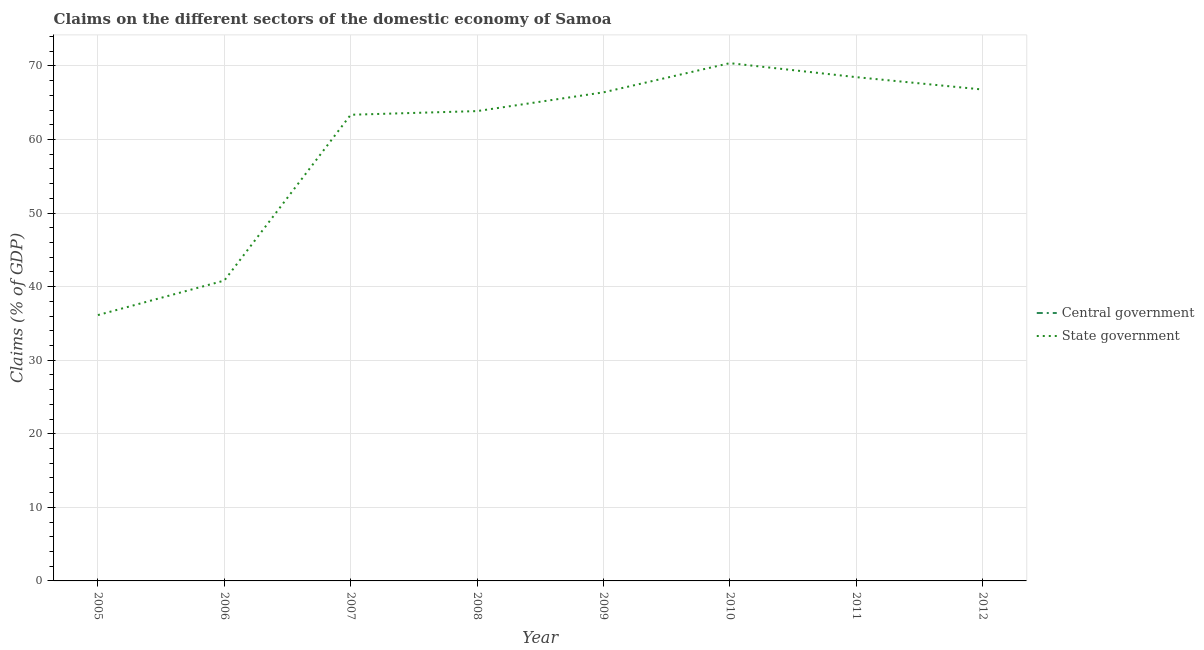Is the number of lines equal to the number of legend labels?
Offer a very short reply. No. What is the claims on state government in 2005?
Offer a terse response. 36.13. Across all years, what is the maximum claims on state government?
Provide a short and direct response. 70.37. Across all years, what is the minimum claims on central government?
Your answer should be very brief. 0. What is the total claims on state government in the graph?
Offer a very short reply. 476.19. What is the difference between the claims on state government in 2005 and that in 2006?
Keep it short and to the point. -4.69. What is the difference between the claims on state government in 2011 and the claims on central government in 2005?
Make the answer very short. 68.47. What is the average claims on state government per year?
Your answer should be very brief. 59.52. In how many years, is the claims on state government greater than 4 %?
Provide a succinct answer. 8. What is the ratio of the claims on state government in 2010 to that in 2012?
Provide a succinct answer. 1.05. What is the difference between the highest and the second highest claims on state government?
Keep it short and to the point. 1.9. What is the difference between the highest and the lowest claims on state government?
Your answer should be very brief. 34.24. In how many years, is the claims on central government greater than the average claims on central government taken over all years?
Keep it short and to the point. 0. How many years are there in the graph?
Your response must be concise. 8. What is the difference between two consecutive major ticks on the Y-axis?
Your answer should be compact. 10. Does the graph contain any zero values?
Make the answer very short. Yes. Does the graph contain grids?
Offer a terse response. Yes. Where does the legend appear in the graph?
Ensure brevity in your answer.  Center right. How are the legend labels stacked?
Provide a succinct answer. Vertical. What is the title of the graph?
Offer a terse response. Claims on the different sectors of the domestic economy of Samoa. Does "Register a property" appear as one of the legend labels in the graph?
Offer a very short reply. No. What is the label or title of the Y-axis?
Offer a terse response. Claims (% of GDP). What is the Claims (% of GDP) in State government in 2005?
Keep it short and to the point. 36.13. What is the Claims (% of GDP) in State government in 2006?
Offer a terse response. 40.82. What is the Claims (% of GDP) of State government in 2007?
Keep it short and to the point. 63.36. What is the Claims (% of GDP) in Central government in 2008?
Keep it short and to the point. 0. What is the Claims (% of GDP) of State government in 2008?
Offer a terse response. 63.85. What is the Claims (% of GDP) of Central government in 2009?
Keep it short and to the point. 0. What is the Claims (% of GDP) of State government in 2009?
Keep it short and to the point. 66.4. What is the Claims (% of GDP) in State government in 2010?
Ensure brevity in your answer.  70.37. What is the Claims (% of GDP) of Central government in 2011?
Your answer should be compact. 0. What is the Claims (% of GDP) of State government in 2011?
Provide a succinct answer. 68.47. What is the Claims (% of GDP) of State government in 2012?
Keep it short and to the point. 66.79. Across all years, what is the maximum Claims (% of GDP) in State government?
Give a very brief answer. 70.37. Across all years, what is the minimum Claims (% of GDP) in State government?
Offer a very short reply. 36.13. What is the total Claims (% of GDP) of Central government in the graph?
Keep it short and to the point. 0. What is the total Claims (% of GDP) of State government in the graph?
Your answer should be compact. 476.19. What is the difference between the Claims (% of GDP) of State government in 2005 and that in 2006?
Make the answer very short. -4.69. What is the difference between the Claims (% of GDP) in State government in 2005 and that in 2007?
Offer a very short reply. -27.22. What is the difference between the Claims (% of GDP) of State government in 2005 and that in 2008?
Keep it short and to the point. -27.72. What is the difference between the Claims (% of GDP) of State government in 2005 and that in 2009?
Your response must be concise. -30.27. What is the difference between the Claims (% of GDP) of State government in 2005 and that in 2010?
Your answer should be compact. -34.24. What is the difference between the Claims (% of GDP) in State government in 2005 and that in 2011?
Your answer should be very brief. -32.34. What is the difference between the Claims (% of GDP) in State government in 2005 and that in 2012?
Provide a succinct answer. -30.65. What is the difference between the Claims (% of GDP) of State government in 2006 and that in 2007?
Your answer should be very brief. -22.53. What is the difference between the Claims (% of GDP) in State government in 2006 and that in 2008?
Your answer should be compact. -23.03. What is the difference between the Claims (% of GDP) of State government in 2006 and that in 2009?
Provide a succinct answer. -25.58. What is the difference between the Claims (% of GDP) in State government in 2006 and that in 2010?
Offer a very short reply. -29.55. What is the difference between the Claims (% of GDP) in State government in 2006 and that in 2011?
Ensure brevity in your answer.  -27.65. What is the difference between the Claims (% of GDP) in State government in 2006 and that in 2012?
Offer a very short reply. -25.96. What is the difference between the Claims (% of GDP) of State government in 2007 and that in 2008?
Make the answer very short. -0.5. What is the difference between the Claims (% of GDP) in State government in 2007 and that in 2009?
Offer a terse response. -3.05. What is the difference between the Claims (% of GDP) in State government in 2007 and that in 2010?
Offer a terse response. -7.01. What is the difference between the Claims (% of GDP) of State government in 2007 and that in 2011?
Offer a terse response. -5.11. What is the difference between the Claims (% of GDP) in State government in 2007 and that in 2012?
Ensure brevity in your answer.  -3.43. What is the difference between the Claims (% of GDP) of State government in 2008 and that in 2009?
Make the answer very short. -2.55. What is the difference between the Claims (% of GDP) in State government in 2008 and that in 2010?
Your answer should be very brief. -6.52. What is the difference between the Claims (% of GDP) in State government in 2008 and that in 2011?
Keep it short and to the point. -4.62. What is the difference between the Claims (% of GDP) of State government in 2008 and that in 2012?
Provide a succinct answer. -2.93. What is the difference between the Claims (% of GDP) of State government in 2009 and that in 2010?
Provide a short and direct response. -3.97. What is the difference between the Claims (% of GDP) of State government in 2009 and that in 2011?
Your answer should be compact. -2.07. What is the difference between the Claims (% of GDP) in State government in 2009 and that in 2012?
Ensure brevity in your answer.  -0.38. What is the difference between the Claims (% of GDP) of State government in 2010 and that in 2011?
Your response must be concise. 1.9. What is the difference between the Claims (% of GDP) of State government in 2010 and that in 2012?
Your answer should be very brief. 3.58. What is the difference between the Claims (% of GDP) of State government in 2011 and that in 2012?
Give a very brief answer. 1.68. What is the average Claims (% of GDP) in State government per year?
Keep it short and to the point. 59.52. What is the ratio of the Claims (% of GDP) of State government in 2005 to that in 2006?
Offer a very short reply. 0.89. What is the ratio of the Claims (% of GDP) in State government in 2005 to that in 2007?
Keep it short and to the point. 0.57. What is the ratio of the Claims (% of GDP) of State government in 2005 to that in 2008?
Provide a succinct answer. 0.57. What is the ratio of the Claims (% of GDP) of State government in 2005 to that in 2009?
Offer a terse response. 0.54. What is the ratio of the Claims (% of GDP) in State government in 2005 to that in 2010?
Your response must be concise. 0.51. What is the ratio of the Claims (% of GDP) of State government in 2005 to that in 2011?
Make the answer very short. 0.53. What is the ratio of the Claims (% of GDP) of State government in 2005 to that in 2012?
Give a very brief answer. 0.54. What is the ratio of the Claims (% of GDP) of State government in 2006 to that in 2007?
Your answer should be compact. 0.64. What is the ratio of the Claims (% of GDP) in State government in 2006 to that in 2008?
Make the answer very short. 0.64. What is the ratio of the Claims (% of GDP) of State government in 2006 to that in 2009?
Provide a succinct answer. 0.61. What is the ratio of the Claims (% of GDP) of State government in 2006 to that in 2010?
Your answer should be compact. 0.58. What is the ratio of the Claims (% of GDP) in State government in 2006 to that in 2011?
Provide a short and direct response. 0.6. What is the ratio of the Claims (% of GDP) of State government in 2006 to that in 2012?
Your answer should be compact. 0.61. What is the ratio of the Claims (% of GDP) of State government in 2007 to that in 2009?
Give a very brief answer. 0.95. What is the ratio of the Claims (% of GDP) of State government in 2007 to that in 2010?
Your answer should be compact. 0.9. What is the ratio of the Claims (% of GDP) in State government in 2007 to that in 2011?
Keep it short and to the point. 0.93. What is the ratio of the Claims (% of GDP) of State government in 2007 to that in 2012?
Provide a short and direct response. 0.95. What is the ratio of the Claims (% of GDP) in State government in 2008 to that in 2009?
Your answer should be compact. 0.96. What is the ratio of the Claims (% of GDP) in State government in 2008 to that in 2010?
Offer a terse response. 0.91. What is the ratio of the Claims (% of GDP) of State government in 2008 to that in 2011?
Your answer should be very brief. 0.93. What is the ratio of the Claims (% of GDP) in State government in 2008 to that in 2012?
Give a very brief answer. 0.96. What is the ratio of the Claims (% of GDP) in State government in 2009 to that in 2010?
Keep it short and to the point. 0.94. What is the ratio of the Claims (% of GDP) in State government in 2009 to that in 2011?
Make the answer very short. 0.97. What is the ratio of the Claims (% of GDP) in State government in 2009 to that in 2012?
Offer a terse response. 0.99. What is the ratio of the Claims (% of GDP) in State government in 2010 to that in 2011?
Ensure brevity in your answer.  1.03. What is the ratio of the Claims (% of GDP) of State government in 2010 to that in 2012?
Keep it short and to the point. 1.05. What is the ratio of the Claims (% of GDP) in State government in 2011 to that in 2012?
Offer a very short reply. 1.03. What is the difference between the highest and the second highest Claims (% of GDP) in State government?
Make the answer very short. 1.9. What is the difference between the highest and the lowest Claims (% of GDP) in State government?
Your answer should be compact. 34.24. 